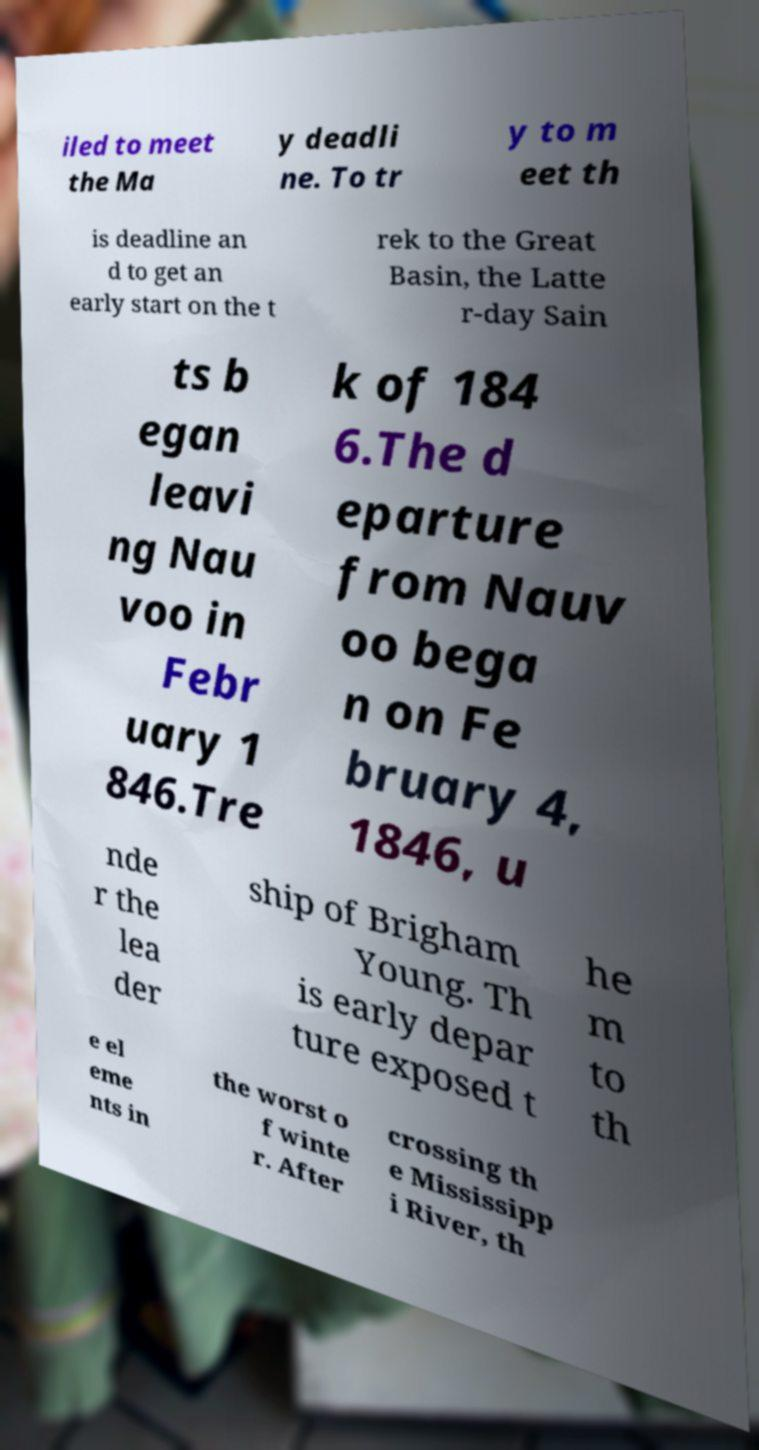Can you accurately transcribe the text from the provided image for me? iled to meet the Ma y deadli ne. To tr y to m eet th is deadline an d to get an early start on the t rek to the Great Basin, the Latte r-day Sain ts b egan leavi ng Nau voo in Febr uary 1 846.Tre k of 184 6.The d eparture from Nauv oo bega n on Fe bruary 4, 1846, u nde r the lea der ship of Brigham Young. Th is early depar ture exposed t he m to th e el eme nts in the worst o f winte r. After crossing th e Mississipp i River, th 